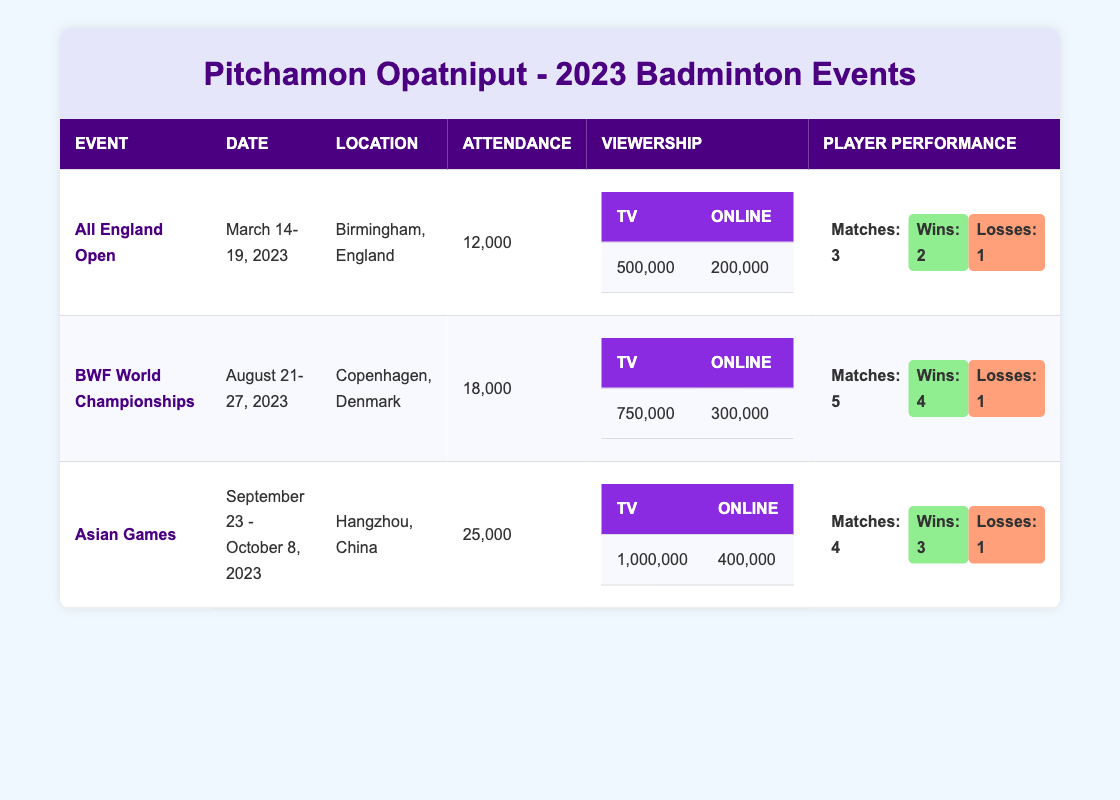What is the total attendance across all major tournaments featuring Pitchamon Opatniput in 2023? The total attendance for each tournament is as follows: All England Open (12,000), BWF World Championships (18,000), and Asian Games (25,000). We add these values: 12,000 + 18,000 + 25,000 = 55,000.
Answer: 55,000 Which tournament had the highest viewership on TV? The viewership on TV for each tournament is: All England Open (500,000), BWF World Championships (750,000), and Asian Games (1,000,000). The highest viewership is from the Asian Games.
Answer: Asian Games Did Pitchamon Opatniput win more matches than he lost in the All England Open tournament? In the All England Open, Pitchamon played 3 matches, won 2, and lost 1. Since 2 (wins) is greater than 1 (loss), he won more matches than he lost.
Answer: Yes What is the average viewership (TV + online) for the BWF World Championships? The viewership for BWF World Championships is 750,000 on TV and 300,000 online. We add these values: 750,000 + 300,000 = 1,050,000. The average is 1,050,000 divided by 2 (because there are 2 categories) which equals 525,000.
Answer: 525,000 Which tournament had the lowest attendance? The attendance for each tournament is: All England Open (12,000), BWF World Championships (18,000), and Asian Games (25,000). The lowest attendance comes from the All England Open.
Answer: All England Open How many total matches did Pitchamon Opatniput play across all tournaments? The matches played by Pitchamon are: 3 in the All England Open, 5 in BWF World Championships, and 4 in Asian Games. Adding these gives us: 3 + 5 + 4 = 12 total matches played.
Answer: 12 Was the online viewership for the Asian Games greater than that of the All England Open? The online viewership was 400,000 for the Asian Games and 200,000 for the All England Open. Since 400,000 is greater than 200,000, the statement is true.
Answer: Yes What was the loss rate of Pitchamon Opatniput in the BWF World Championships? In the BWF World Championships, Pitchamon played 5 matches and lost 1. The loss rate can be calculated as: (1 loss / 5 matches) * 100% = 20%.
Answer: 20% 